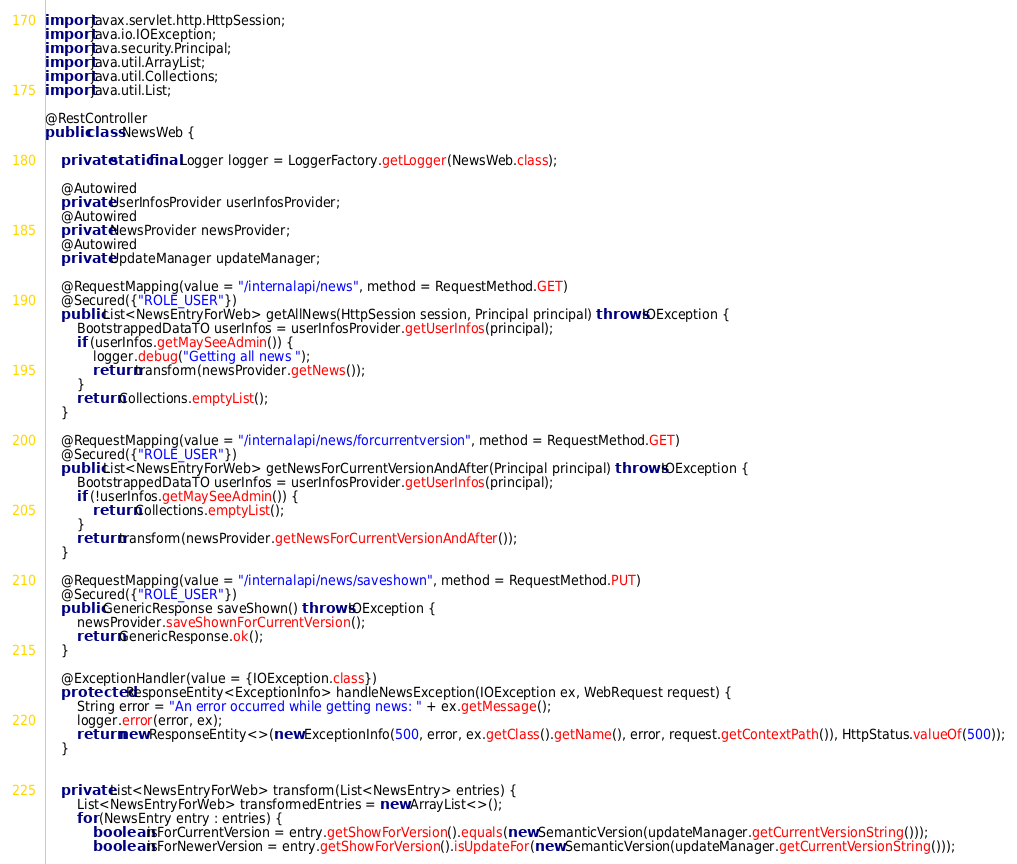<code> <loc_0><loc_0><loc_500><loc_500><_Java_>
import javax.servlet.http.HttpSession;
import java.io.IOException;
import java.security.Principal;
import java.util.ArrayList;
import java.util.Collections;
import java.util.List;

@RestController
public class NewsWeb {

    private static final Logger logger = LoggerFactory.getLogger(NewsWeb.class);

    @Autowired
    private UserInfosProvider userInfosProvider;
    @Autowired
    private NewsProvider newsProvider;
    @Autowired
    private UpdateManager updateManager;

    @RequestMapping(value = "/internalapi/news", method = RequestMethod.GET)
    @Secured({"ROLE_USER"})
    public List<NewsEntryForWeb> getAllNews(HttpSession session, Principal principal) throws IOException {
        BootstrappedDataTO userInfos = userInfosProvider.getUserInfos(principal);
        if (userInfos.getMaySeeAdmin()) {
            logger.debug("Getting all news ");
            return transform(newsProvider.getNews());
        }
        return Collections.emptyList();
    }

    @RequestMapping(value = "/internalapi/news/forcurrentversion", method = RequestMethod.GET)
    @Secured({"ROLE_USER"})
    public List<NewsEntryForWeb> getNewsForCurrentVersionAndAfter(Principal principal) throws IOException {
        BootstrappedDataTO userInfos = userInfosProvider.getUserInfos(principal);
        if (!userInfos.getMaySeeAdmin()) {
            return Collections.emptyList();
        }
        return transform(newsProvider.getNewsForCurrentVersionAndAfter());
    }

    @RequestMapping(value = "/internalapi/news/saveshown", method = RequestMethod.PUT)
    @Secured({"ROLE_USER"})
    public GenericResponse saveShown() throws IOException {
        newsProvider.saveShownForCurrentVersion();
        return GenericResponse.ok();
    }

    @ExceptionHandler(value = {IOException.class})
    protected ResponseEntity<ExceptionInfo> handleNewsException(IOException ex, WebRequest request) {
        String error = "An error occurred while getting news: " + ex.getMessage();
        logger.error(error, ex);
        return new ResponseEntity<>(new ExceptionInfo(500, error, ex.getClass().getName(), error, request.getContextPath()), HttpStatus.valueOf(500));
    }


    private List<NewsEntryForWeb> transform(List<NewsEntry> entries) {
        List<NewsEntryForWeb> transformedEntries = new ArrayList<>();
        for (NewsEntry entry : entries) {
            boolean isForCurrentVersion = entry.getShowForVersion().equals(new SemanticVersion(updateManager.getCurrentVersionString()));
            boolean isForNewerVersion = entry.getShowForVersion().isUpdateFor(new SemanticVersion(updateManager.getCurrentVersionString()));</code> 